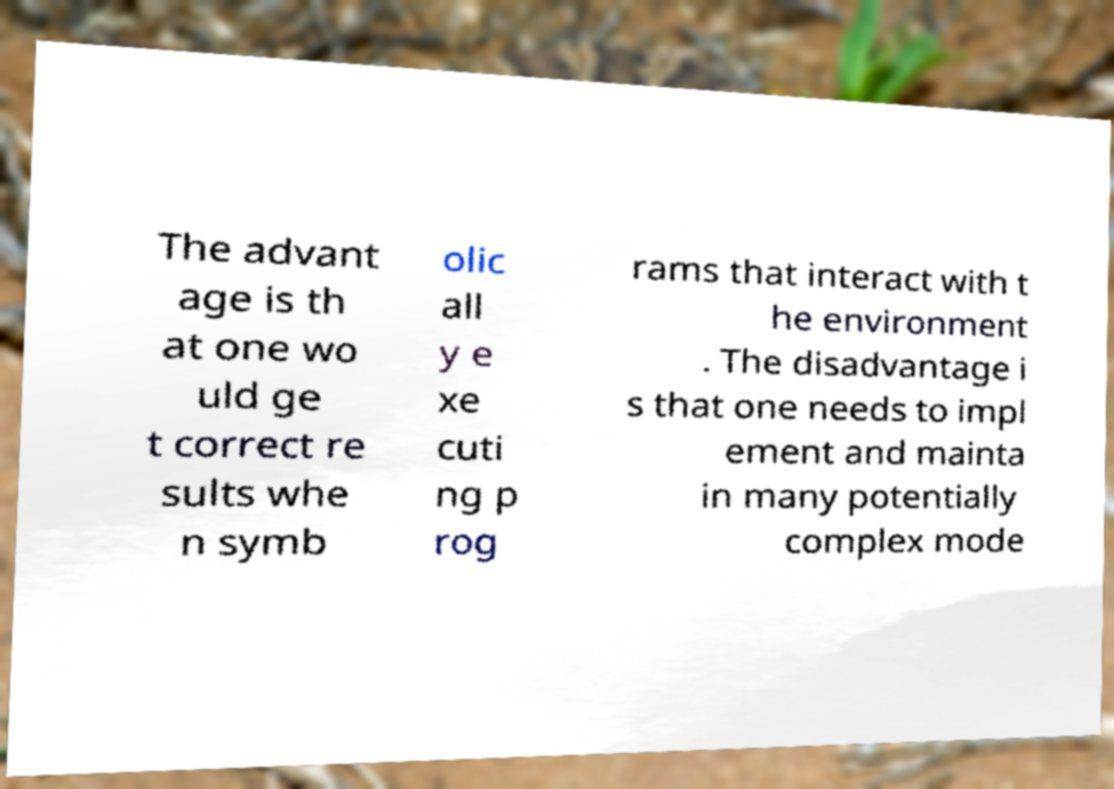Could you extract and type out the text from this image? The advant age is th at one wo uld ge t correct re sults whe n symb olic all y e xe cuti ng p rog rams that interact with t he environment . The disadvantage i s that one needs to impl ement and mainta in many potentially complex mode 